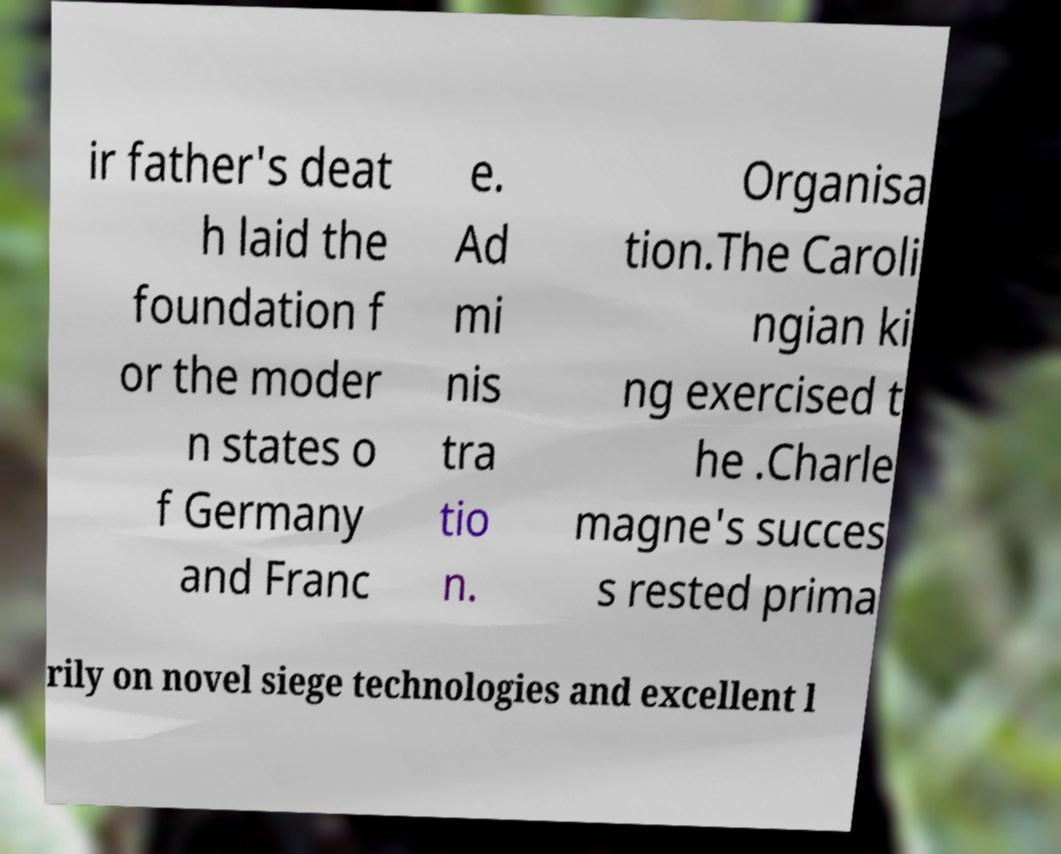What messages or text are displayed in this image? I need them in a readable, typed format. ir father's deat h laid the foundation f or the moder n states o f Germany and Franc e. Ad mi nis tra tio n. Organisa tion.The Caroli ngian ki ng exercised t he .Charle magne's succes s rested prima rily on novel siege technologies and excellent l 